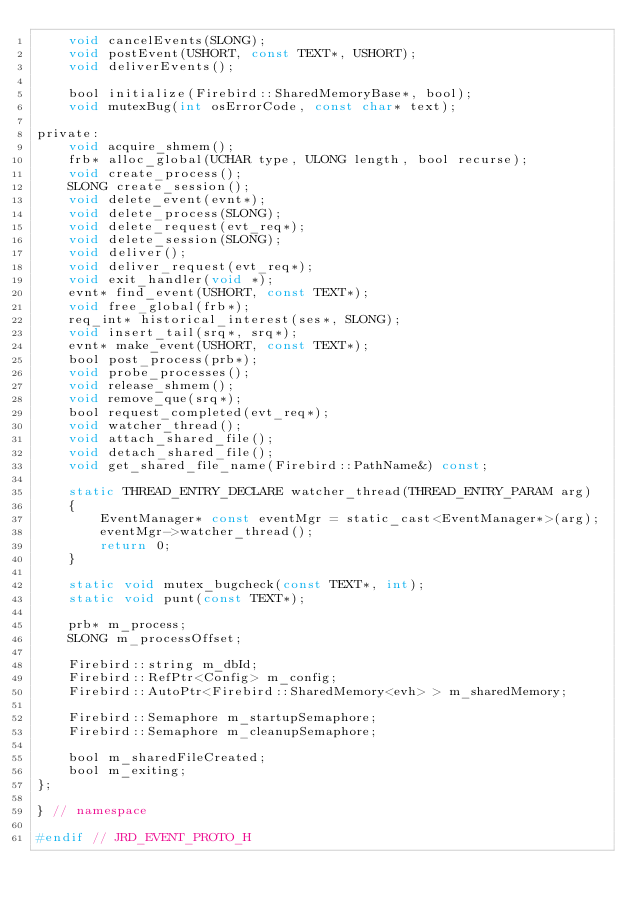<code> <loc_0><loc_0><loc_500><loc_500><_C_>	void cancelEvents(SLONG);
	void postEvent(USHORT, const TEXT*, USHORT);
	void deliverEvents();

	bool initialize(Firebird::SharedMemoryBase*, bool);
	void mutexBug(int osErrorCode, const char* text);

private:
	void acquire_shmem();
	frb* alloc_global(UCHAR type, ULONG length, bool recurse);
	void create_process();
	SLONG create_session();
	void delete_event(evnt*);
	void delete_process(SLONG);
	void delete_request(evt_req*);
	void delete_session(SLONG);
	void deliver();
	void deliver_request(evt_req*);
	void exit_handler(void *);
	evnt* find_event(USHORT, const TEXT*);
	void free_global(frb*);
	req_int* historical_interest(ses*, SLONG);
	void insert_tail(srq*, srq*);
	evnt* make_event(USHORT, const TEXT*);
	bool post_process(prb*);
	void probe_processes();
	void release_shmem();
	void remove_que(srq*);
	bool request_completed(evt_req*);
	void watcher_thread();
	void attach_shared_file();
	void detach_shared_file();
	void get_shared_file_name(Firebird::PathName&) const;

	static THREAD_ENTRY_DECLARE watcher_thread(THREAD_ENTRY_PARAM arg)
	{
		EventManager* const eventMgr = static_cast<EventManager*>(arg);
		eventMgr->watcher_thread();
		return 0;
	}

	static void mutex_bugcheck(const TEXT*, int);
	static void punt(const TEXT*);

	prb* m_process;
	SLONG m_processOffset;

	Firebird::string m_dbId;
	Firebird::RefPtr<Config> m_config;
	Firebird::AutoPtr<Firebird::SharedMemory<evh> > m_sharedMemory;

	Firebird::Semaphore m_startupSemaphore;
	Firebird::Semaphore m_cleanupSemaphore;

	bool m_sharedFileCreated;
	bool m_exiting;
};

} // namespace

#endif // JRD_EVENT_PROTO_H
</code> 